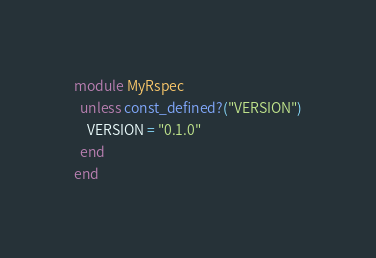Convert code to text. <code><loc_0><loc_0><loc_500><loc_500><_Ruby_>module MyRspec
  unless const_defined?("VERSION")
    VERSION = "0.1.0"
  end
end
</code> 